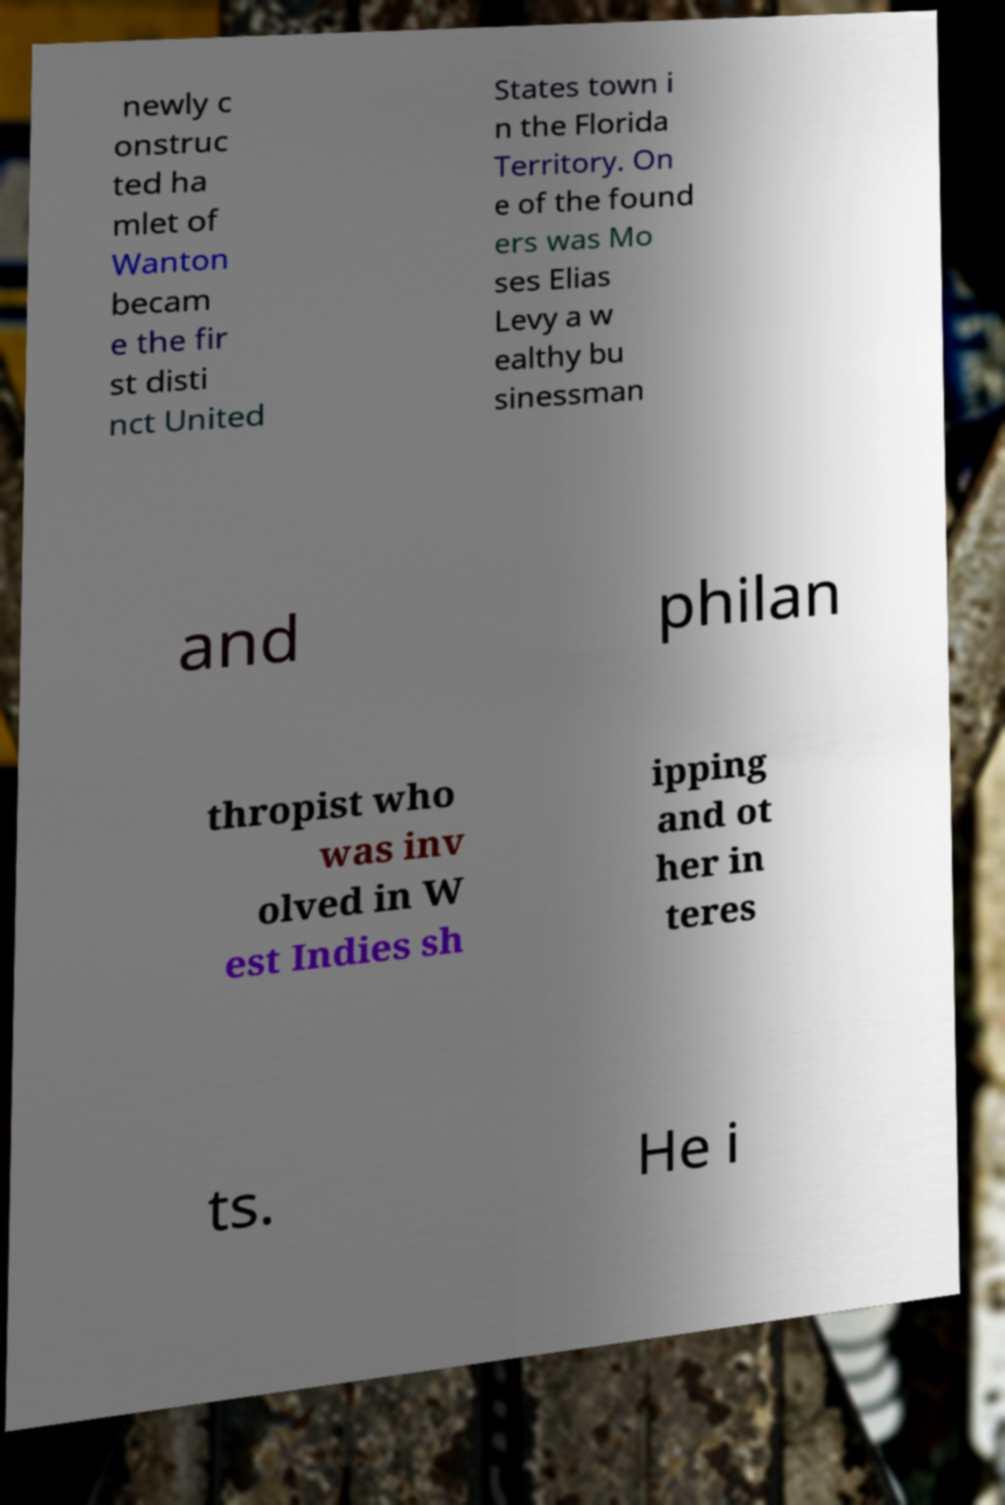I need the written content from this picture converted into text. Can you do that? newly c onstruc ted ha mlet of Wanton becam e the fir st disti nct United States town i n the Florida Territory. On e of the found ers was Mo ses Elias Levy a w ealthy bu sinessman and philan thropist who was inv olved in W est Indies sh ipping and ot her in teres ts. He i 